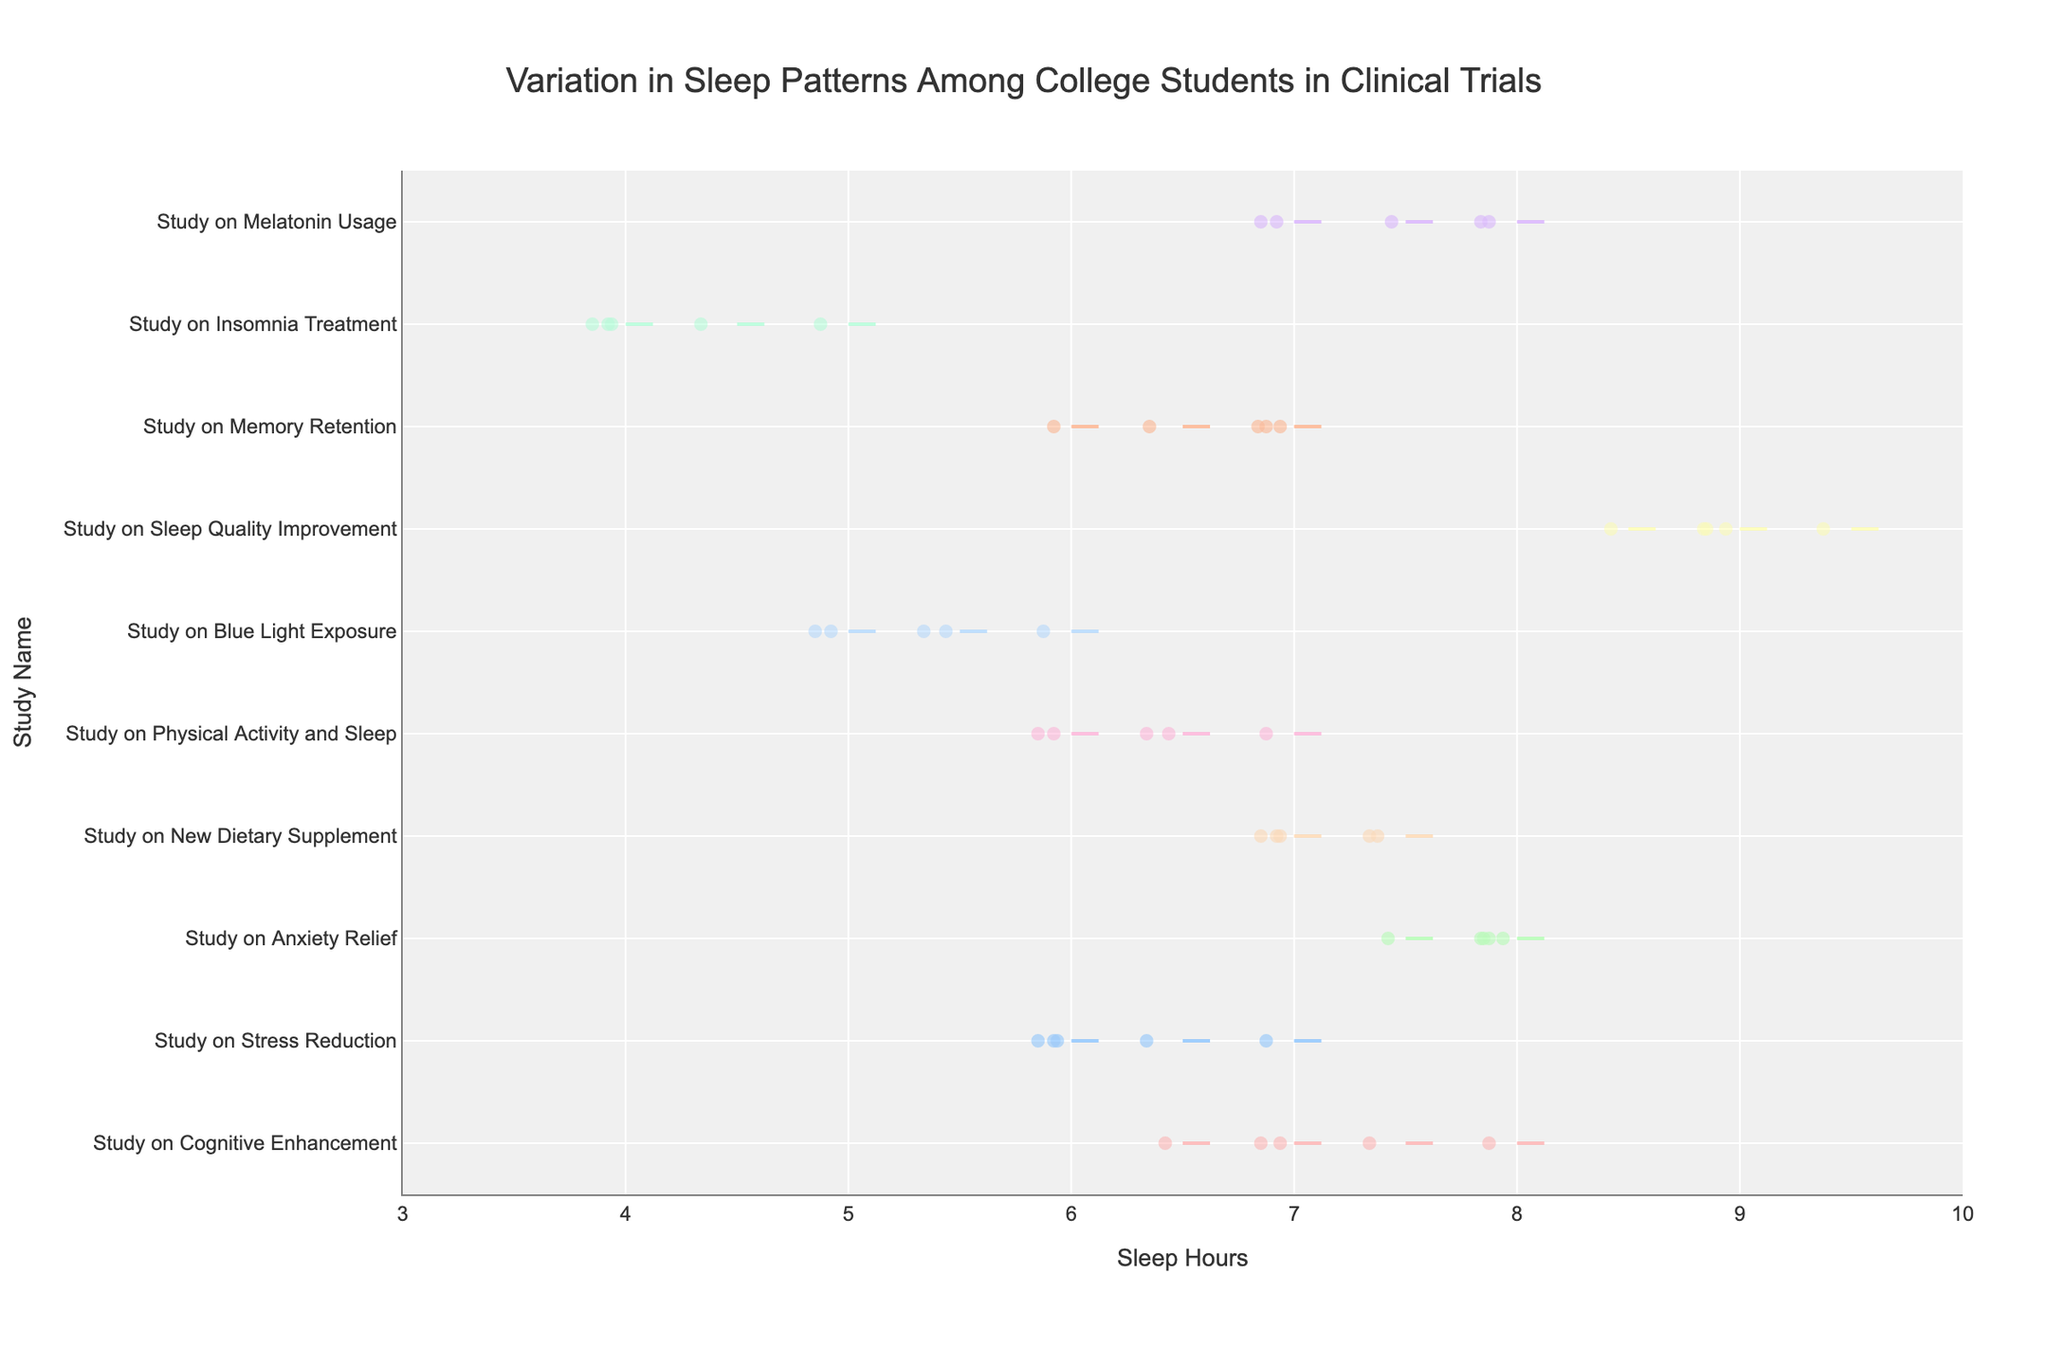What is the title of the figure? The title is located at the top of the figure and is generally displayed prominently in font size and color.
Answer: Variation in Sleep Patterns Among College Students in Clinical Trials What is the range of sleep hours shown on the x-axis? The range of sleep hours can be identified by looking at the lower and upper limits marked on the x-axis.
Answer: 3 to 10 Which study has the most variation in sleep hours? To identify the study with the most variation, look for the study with the widest spread in the distribution of sleep hours along the x-axis.
Answer: Study on Insomnia Treatment How many studies are shown in the figure? Count the number of distinct violin plots, which each represent a unique study, along the y-axis.
Answer: 10 Which study has the highest average sleep hours? The average sleep hours can be approximated by the position of the thick line within the violin plot. The study with the highest average will have this line positioned furthest to the right on the x-axis.
Answer: Study on Sleep Quality Improvement What is the median sleep hours for the "Study on New Dietary Supplement"? The median is represented by the central line within the violin plot corresponding to this study. Look for the central position within this particular plot.
Answer: 7.5 hours Is there any study where some participants slept less than 5 hours? Check for any violin plots that extend to the left of the 5-hour mark on the x-axis.
Answer: Yes, at least the Study on Insomnia Treatment Compare the sleep hours of "Study on Cognitive Enhancement" and "Study on Stress Reduction" and identify which one has a higher average. Analyze both violin plots and determine which has the thicker line further to the right on the x-axis, indicating a higher average sleep hours.
Answer: Study on Cognitive Enhancement What is the interquartile range of the "Study on Melatonin Usage"? The interquartile range is the span between the first and third quartiles, which are typically indicated by the edges of the filling within the violin plot.
Answer: Approximately 7 to 8 hours Which study has the smallest spread in sleep hours? Look for the violin plot that is most compressed along the x-axis, indicating the smallest variation in sleep hours.
Answer: Study on Anxiety Relief 